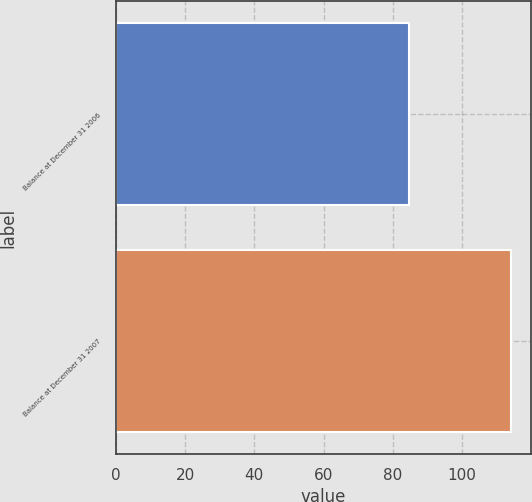<chart> <loc_0><loc_0><loc_500><loc_500><bar_chart><fcel>Balance at December 31 2006<fcel>Balance at December 31 2007<nl><fcel>84.7<fcel>114.1<nl></chart> 